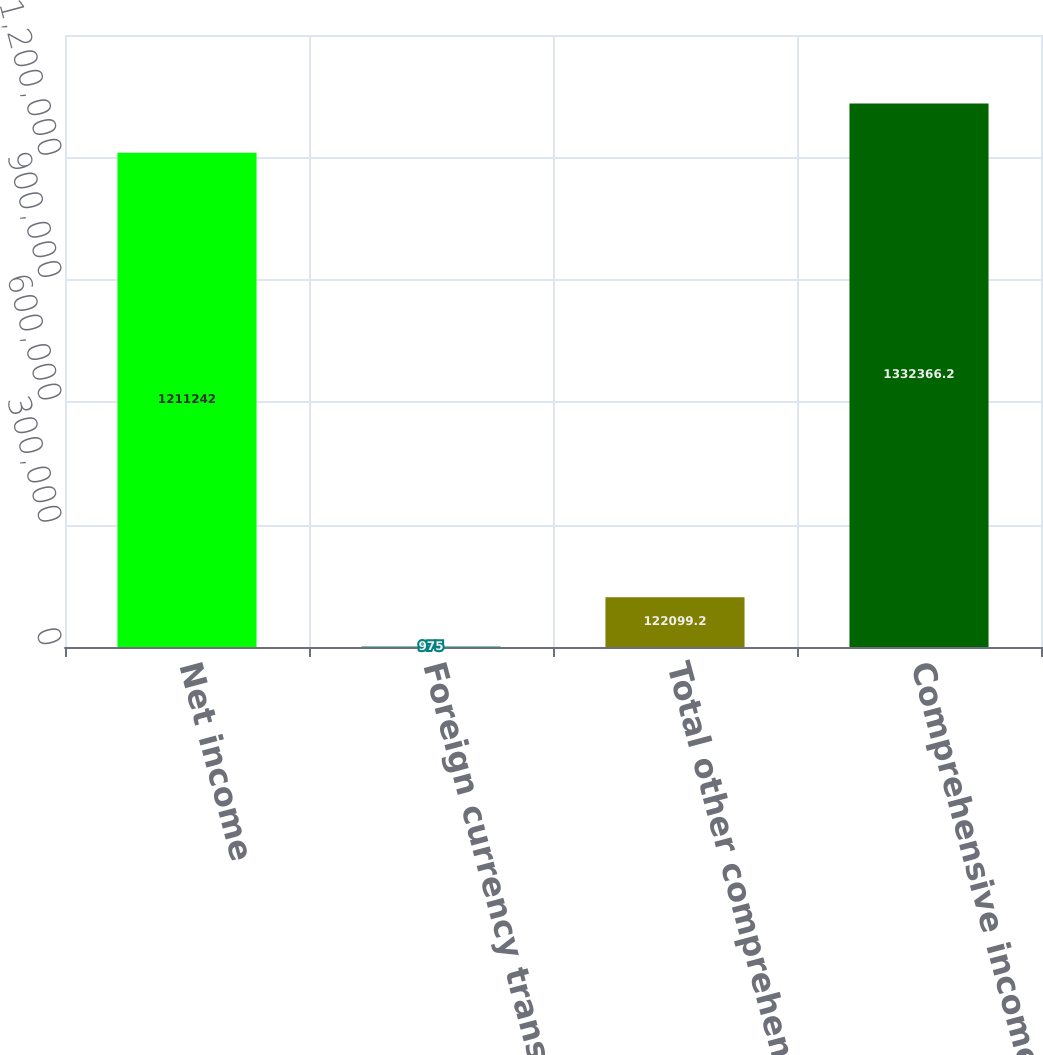Convert chart. <chart><loc_0><loc_0><loc_500><loc_500><bar_chart><fcel>Net income<fcel>Foreign currency translation<fcel>Total other comprehensive<fcel>Comprehensive income<nl><fcel>1.21124e+06<fcel>975<fcel>122099<fcel>1.33237e+06<nl></chart> 